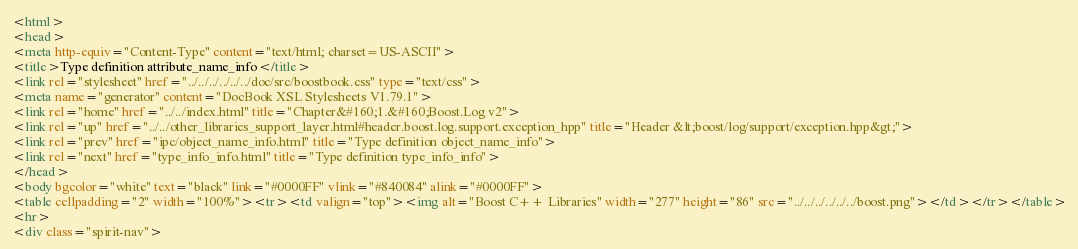Convert code to text. <code><loc_0><loc_0><loc_500><loc_500><_HTML_><html>
<head>
<meta http-equiv="Content-Type" content="text/html; charset=US-ASCII">
<title>Type definition attribute_name_info</title>
<link rel="stylesheet" href="../../../../../../doc/src/boostbook.css" type="text/css">
<meta name="generator" content="DocBook XSL Stylesheets V1.79.1">
<link rel="home" href="../../index.html" title="Chapter&#160;1.&#160;Boost.Log v2">
<link rel="up" href="../../other_libraries_support_layer.html#header.boost.log.support.exception_hpp" title="Header &lt;boost/log/support/exception.hpp&gt;">
<link rel="prev" href="ipc/object_name_info.html" title="Type definition object_name_info">
<link rel="next" href="type_info_info.html" title="Type definition type_info_info">
</head>
<body bgcolor="white" text="black" link="#0000FF" vlink="#840084" alink="#0000FF">
<table cellpadding="2" width="100%"><tr><td valign="top"><img alt="Boost C++ Libraries" width="277" height="86" src="../../../../../../boost.png"></td></tr></table>
<hr>
<div class="spirit-nav"></code> 